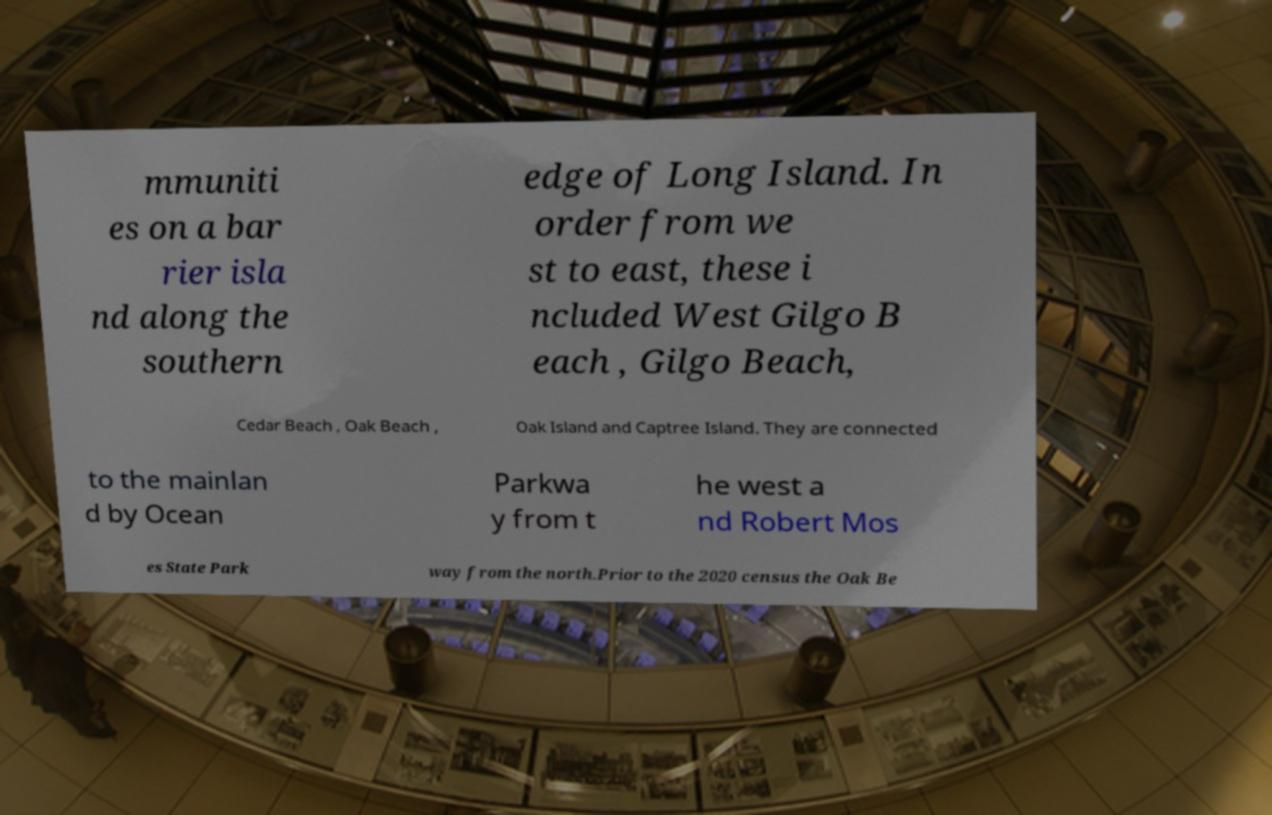For documentation purposes, I need the text within this image transcribed. Could you provide that? mmuniti es on a bar rier isla nd along the southern edge of Long Island. In order from we st to east, these i ncluded West Gilgo B each , Gilgo Beach, Cedar Beach , Oak Beach , Oak Island and Captree Island. They are connected to the mainlan d by Ocean Parkwa y from t he west a nd Robert Mos es State Park way from the north.Prior to the 2020 census the Oak Be 